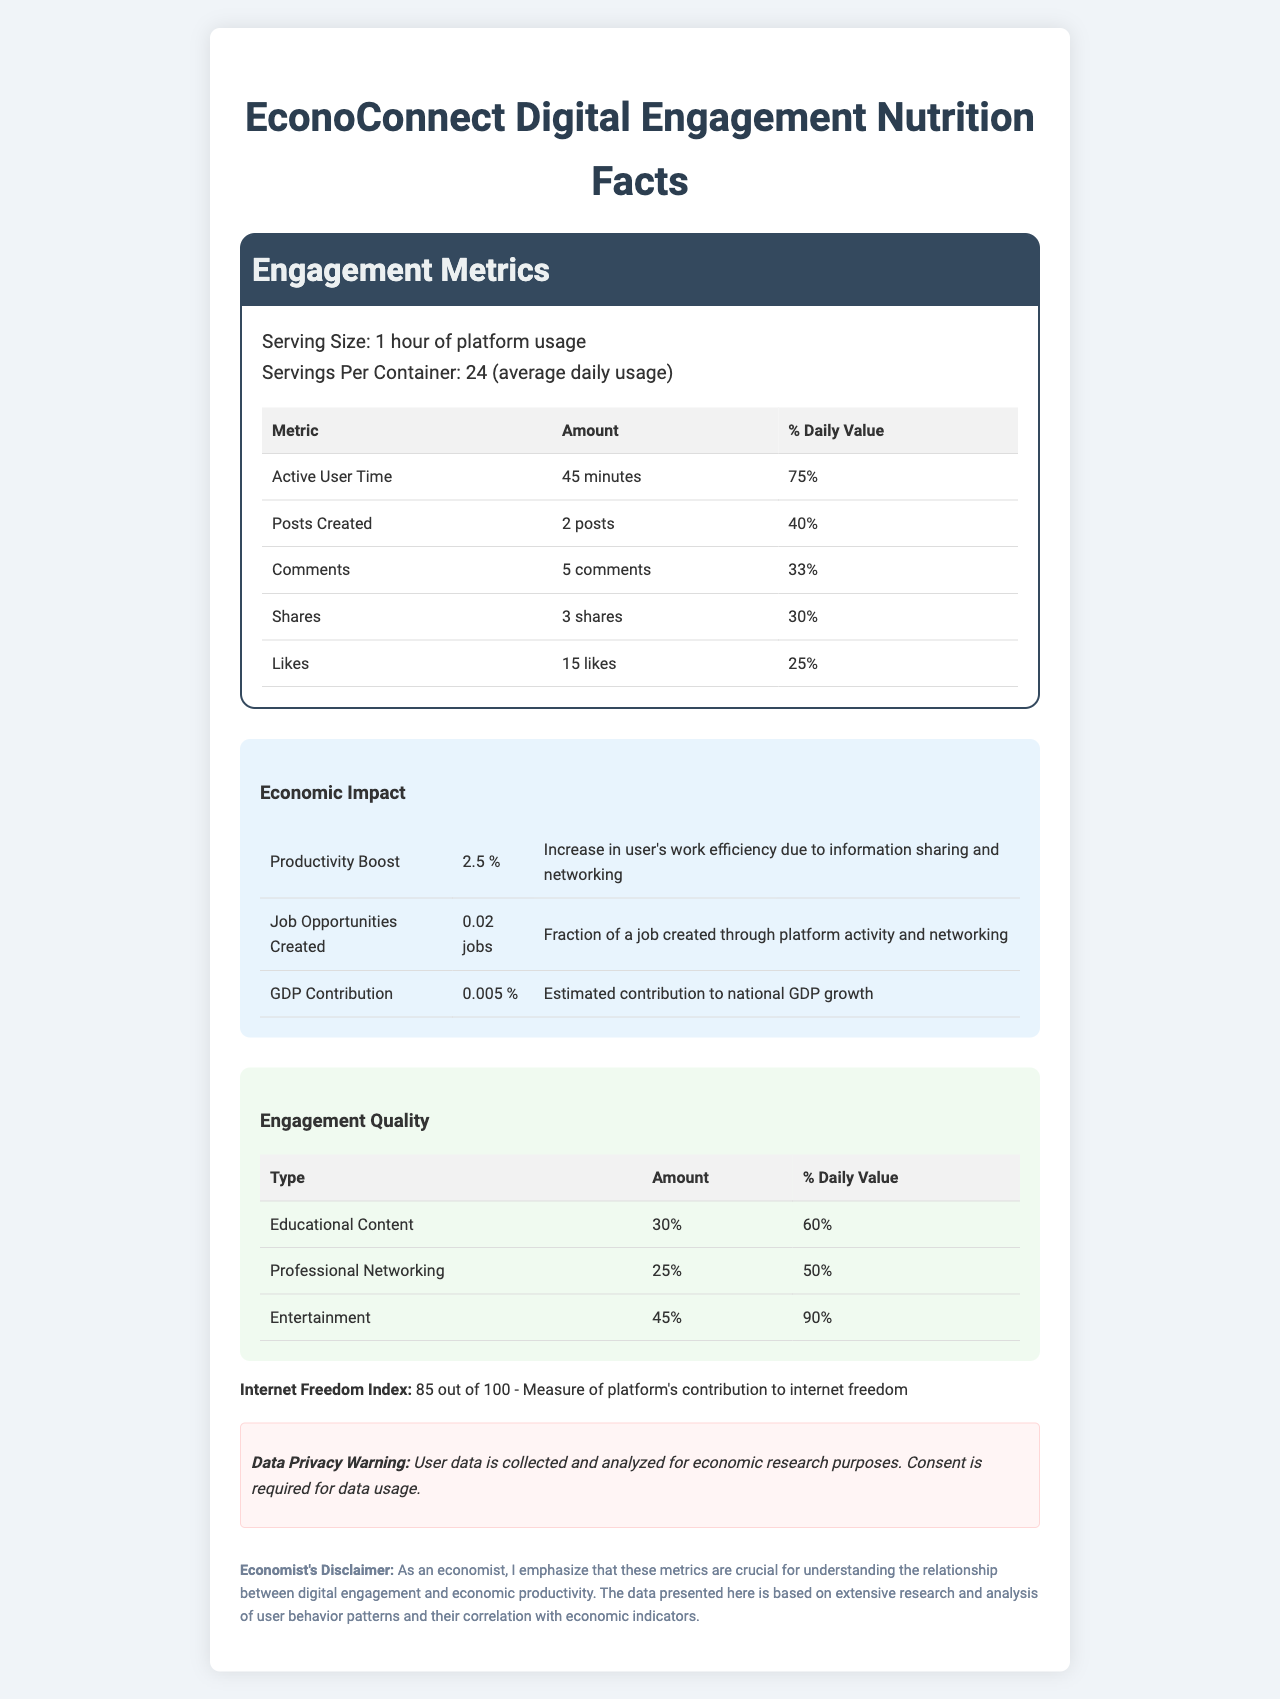what is the serving size? The document specifies that the serving size is "1 hour of platform usage."
Answer: 1 hour of platform usage how many comments does an average user make per serving? The document indicates that the amount of comments per serving is 5 comments.
Answer: 5 comments what is the percentage daily value of likes? The document shows that the percentage daily value of likes is 25%.
Answer: 25% how much does EconoConnect contribute to GDP growth per serving? The economic impact section states that the GDP contribution per serving is 0.005%.
Answer: 0.005% which type of engagement has the highest daily value? The engagement quality section lists entertainment with a 90% daily value, which is higher than educational content and professional networking.
Answer: Entertainment what is the internet freedom index score for EconoConnect? The internet freedom index section indicates that the score is 85 out of 100.
Answer: 85 out of 100 how many posts are created by an average user per day? The document states that the amount of posts created per serving is 2, and given there are 24 servings per container (average daily usage), 2 posts per serving multiplied by 24 servings equals 48 posts per day.
Answer: 48 posts what is the description of the data privacy warning? The data privacy warning section contains this description.
Answer: User data is collected and analyzed for economic research purposes. Consent is required for data usage. which engagement quality type has a higher percentage daily value than professional networking? A. Educational Content B. Entertainment C. Both The percentage daily values for educational content (60%) and entertainment (90%) are both higher than that for professional networking (50%).
Answer: C. Both what are the economic impacts listed for one hour of platform usage? A. Productivity Boost, Job Opportunities Created, GDP Contribution B. Productivity Boost, Internet Freedom, Job Opportunities C. GDP Contribution, Internet Freedom, Engagement Quality The document lists these three metrics under the economic impact section.
Answer: A. Productivity Boost, Job Opportunities Created, GDP Contribution is the engagement metric for shares higher than that for comments? The document mentions that the engagement metric for shares is 3, while for comments it is 5.
Answer: No summarize the main idea of the document The summary captures the content and structure of the document, which presents various user engagement and economic impact metrics in the format of a nutrition label.
Answer: The document is a "digital engagement nutrition facts" label for the platform EconoConnect. It outlines user engagement metrics such as active user time, posts created, comments, shares, and likes, along with their respective daily values. It also highlights economic impacts like productivity boost, job opportunities created, and GDP contribution. Additionally, it provides information on engagement quality, internet freedom index, and a data privacy warning. how much does EconoConnect improve work efficiency per serving? The document specifies a productivity boost of 2.5% per serving.
Answer: 2.5% what is the total time an average user is active on EconoConnect per day? With 24 servings per container (average daily usage) and 45 minutes of active user time per serving, 45 minutes multiplied by 24 servings equals 1080 minutes, or 18 hours per day.
Answer: 18 hours how many job opportunities are created through EconoConnect per hour of usage? The economic impact section indicates that 0.02 jobs are created per hour of platform usage.
Answer: 0.02 jobs what is the data collection and analysis disclaimer for EconoConnect? The document mentions a data privacy warning, but does not provide full details on data collection and analysis methods.
Answer: Not enough information which engagement metric has the lowest daily value percentage? The document shows that shares have a daily value percentage of 30%, which is lower than the percentages for active user time, posts created, comments, and likes.
Answer: Shares 